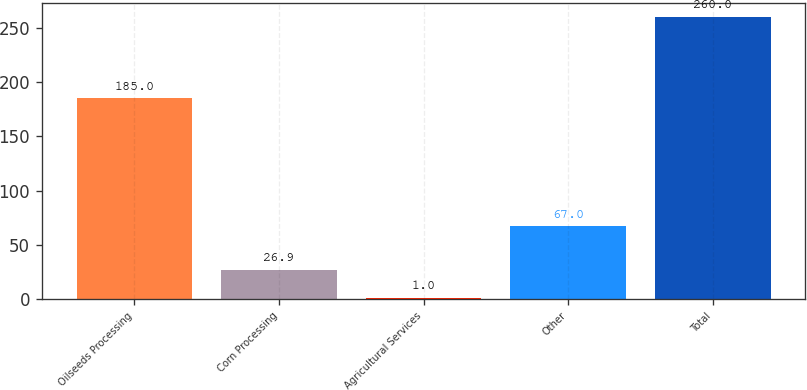Convert chart. <chart><loc_0><loc_0><loc_500><loc_500><bar_chart><fcel>Oilseeds Processing<fcel>Corn Processing<fcel>Agricultural Services<fcel>Other<fcel>Total<nl><fcel>185<fcel>26.9<fcel>1<fcel>67<fcel>260<nl></chart> 